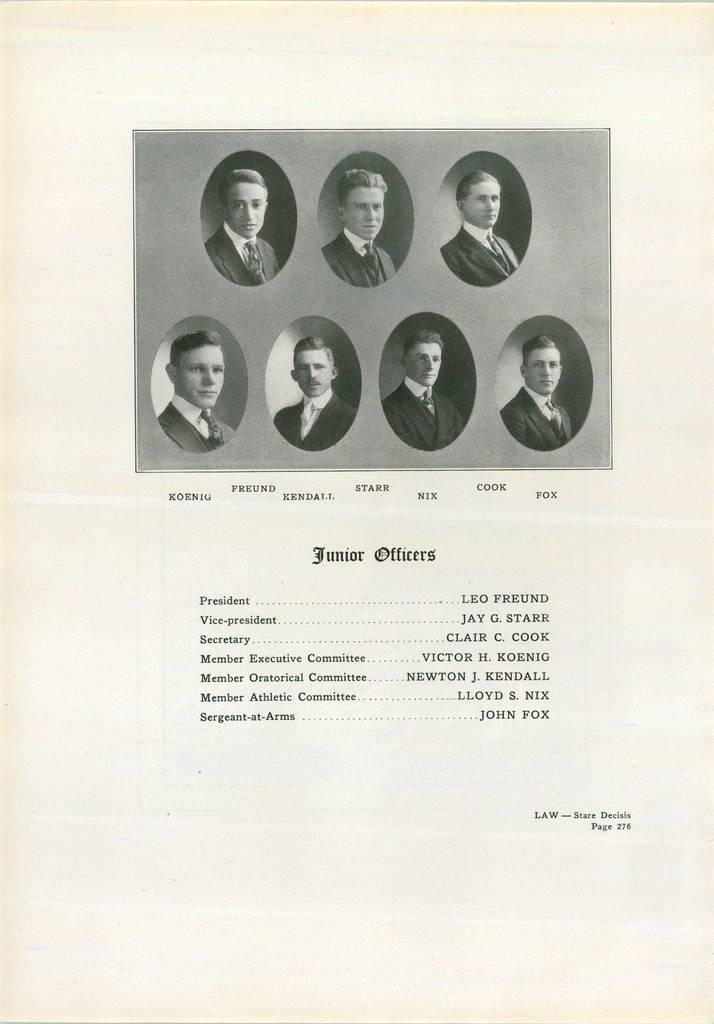What is the nature of the image? The image appears to be printed. What can be found in the image besides the visual elements? There is text present in the image. How many people are in the photo? There are seven persons in the photo. What type of egg is being used to show respect in the image? There is no egg present in the image, nor is there any indication of respect being shown. 